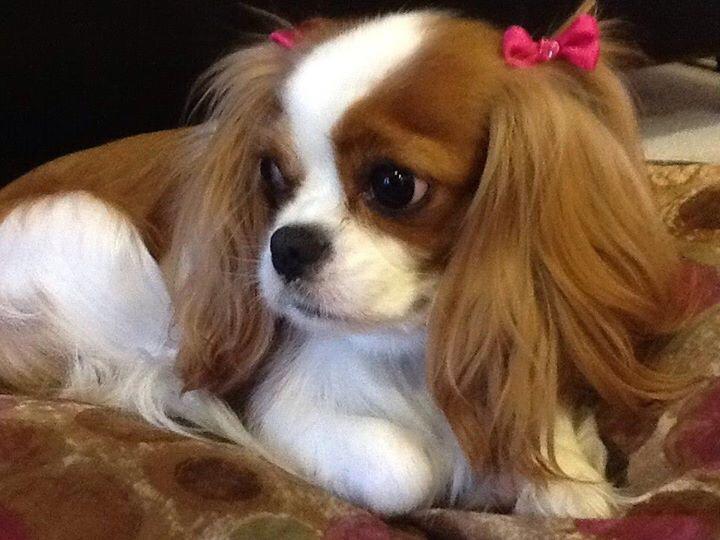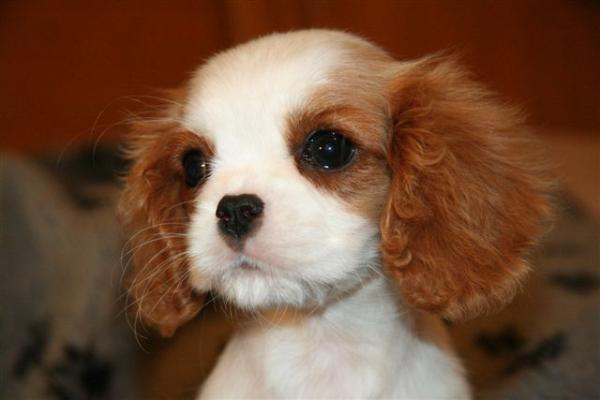The first image is the image on the left, the second image is the image on the right. For the images displayed, is the sentence "At least one image has no grass." factually correct? Answer yes or no. Yes. 